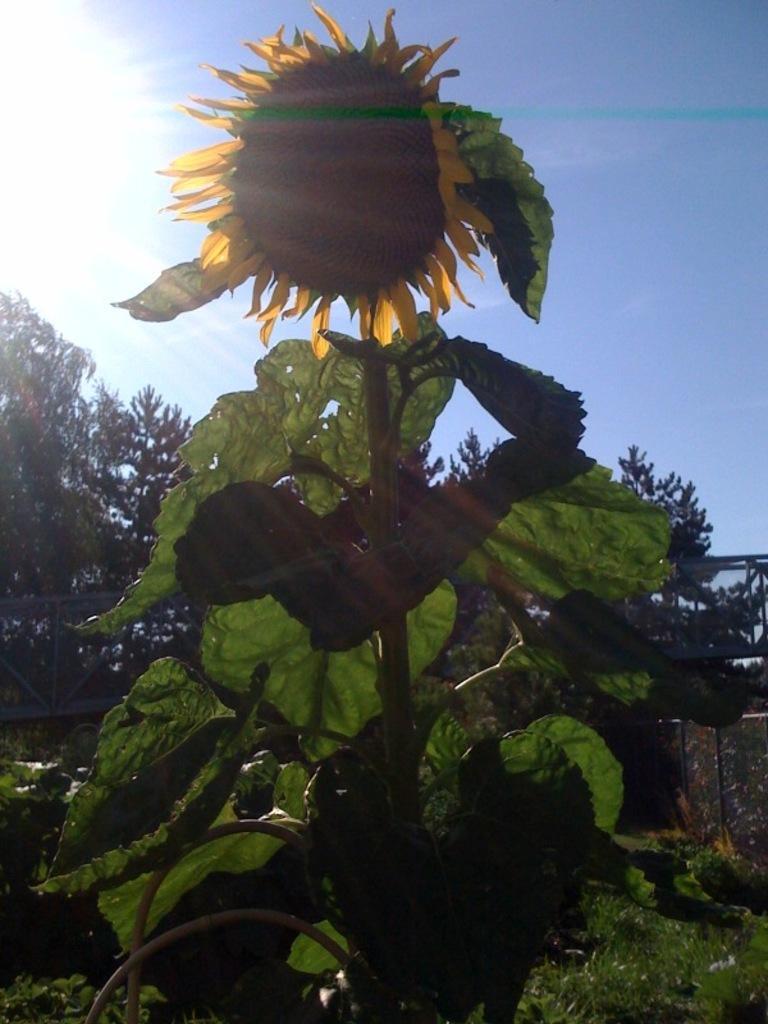In one or two sentences, can you explain what this image depicts? In this picture I can see a plant with a flower, there are trees, and in the background there is the sky. 